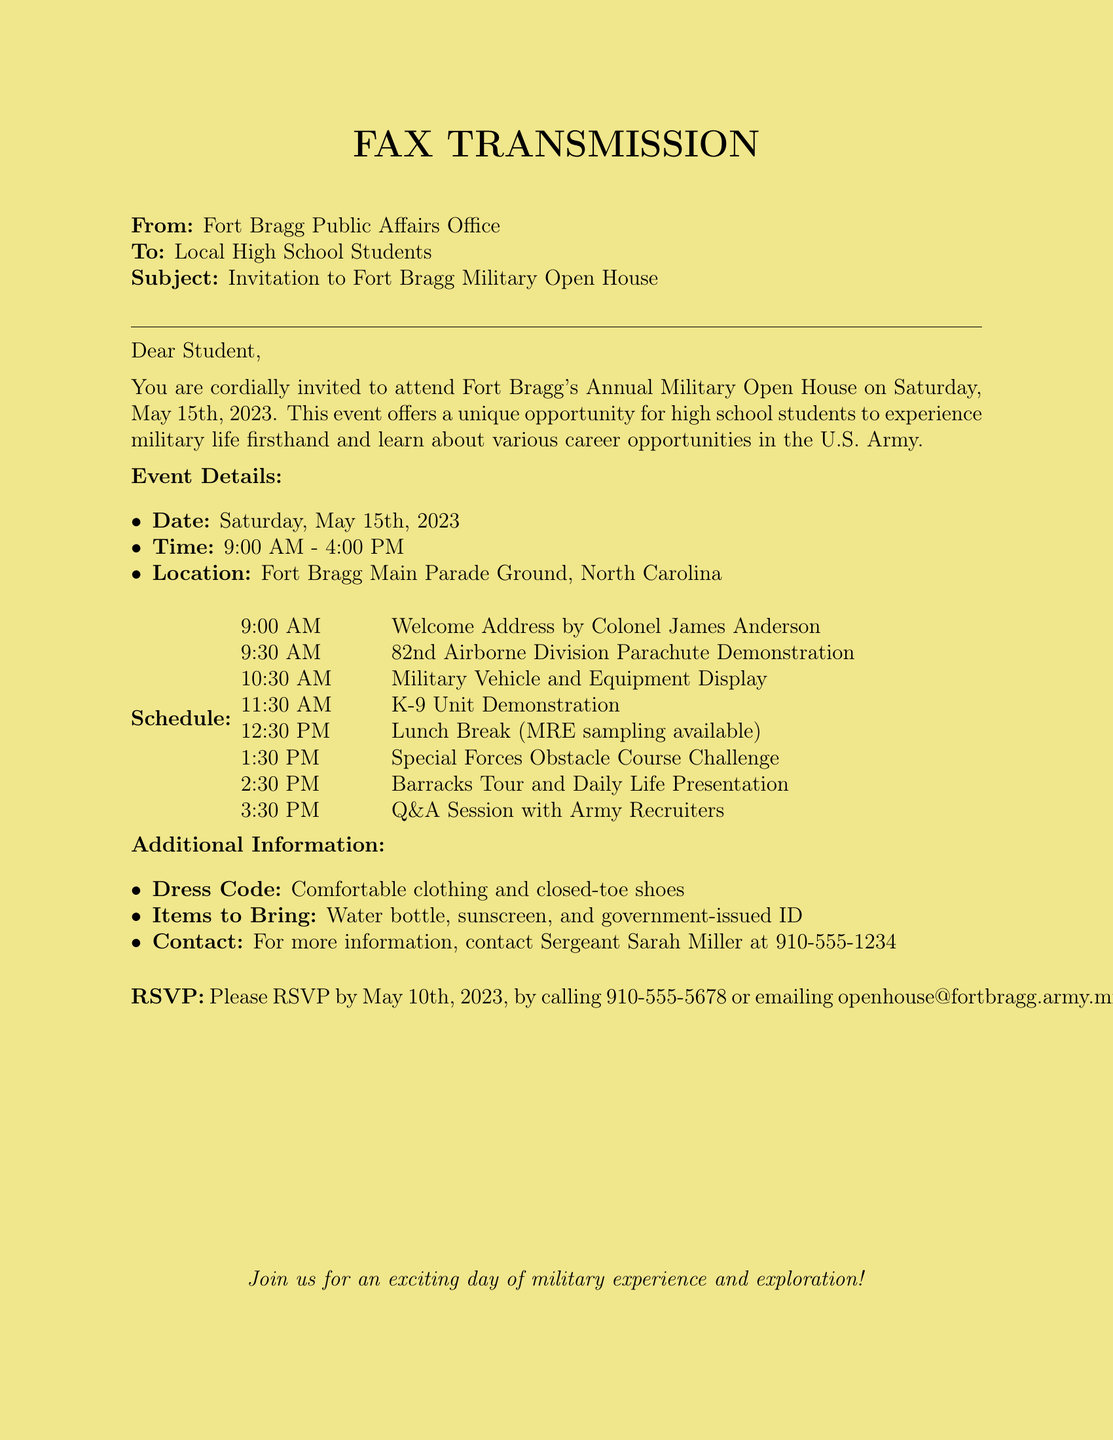What is the date of the event? The date of the event is specified in the document as Saturday, May 15th, 2023.
Answer: Saturday, May 15th, 2023 What time does the event start? The document indicates that the event starts at 9:00 AM.
Answer: 9:00 AM Who will give the welcome address? The name of the person giving the welcome address is mentioned as Colonel James Anderson.
Answer: Colonel James Anderson How long is the lunch break? The document states that the lunch break is from 12:30 PM. to 1:30 PM, making it one hour long.
Answer: One hour What type of demonstration will happen at 10:30 AM? The scheduled demonstration at that time is a Military Vehicle and Equipment Display.
Answer: Military Vehicle and Equipment Display What items should attendees bring? The document lists specific items to bring, including a water bottle, sunscreen, and government-issued ID.
Answer: Water bottle, sunscreen, government-issued ID What is the RSVP deadline? The document mentions that the RSVP must be completed by May 10th, 2023.
Answer: May 10th, 2023 What is the contact number for more information? The contact number provided for more information is 910-555-1234.
Answer: 910-555-1234 What dress code is suggested for the event? The suggested dress code mentioned in the document is comfortable clothing and closed-toe shoes.
Answer: Comfortable clothing and closed-toe shoes 